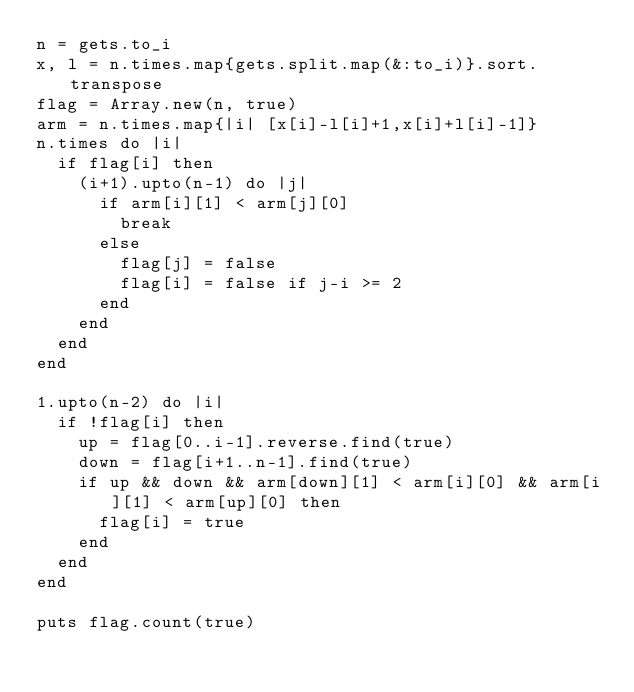<code> <loc_0><loc_0><loc_500><loc_500><_Ruby_>n = gets.to_i
x, l = n.times.map{gets.split.map(&:to_i)}.sort.transpose
flag = Array.new(n, true)
arm = n.times.map{|i| [x[i]-l[i]+1,x[i]+l[i]-1]}
n.times do |i|
  if flag[i] then
    (i+1).upto(n-1) do |j|
      if arm[i][1] < arm[j][0]
        break
      else
        flag[j] = false
        flag[i] = false if j-i >= 2
      end
    end
  end
end

1.upto(n-2) do |i|
  if !flag[i] then
    up = flag[0..i-1].reverse.find(true)
    down = flag[i+1..n-1].find(true)
    if up && down && arm[down][1] < arm[i][0] && arm[i][1] < arm[up][0] then
      flag[i] = true
    end
  end
end

puts flag.count(true)
</code> 